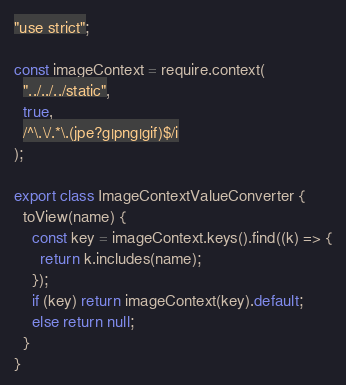Convert code to text. <code><loc_0><loc_0><loc_500><loc_500><_JavaScript_>"use strict";

const imageContext = require.context(
  "../../../static",
  true,
  /^\.\/.*\.(jpe?g|png|gif)$/i
);

export class ImageContextValueConverter {
  toView(name) {
    const key = imageContext.keys().find((k) => {
      return k.includes(name);
    });
    if (key) return imageContext(key).default;
    else return null;
  }
}
</code> 